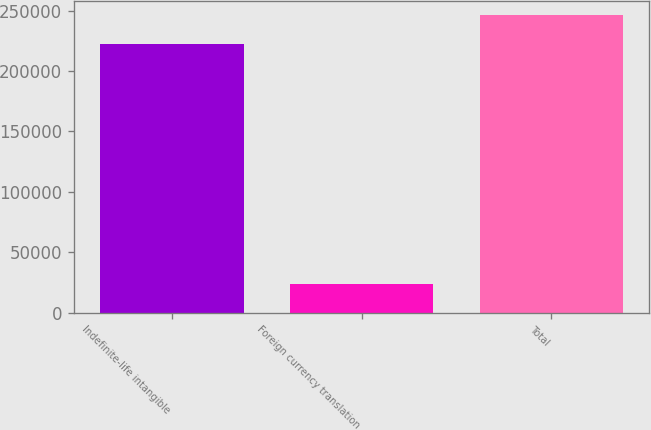Convert chart. <chart><loc_0><loc_0><loc_500><loc_500><bar_chart><fcel>Indefinite-life intangible<fcel>Foreign currency translation<fcel>Total<nl><fcel>222525<fcel>23489<fcel>246014<nl></chart> 